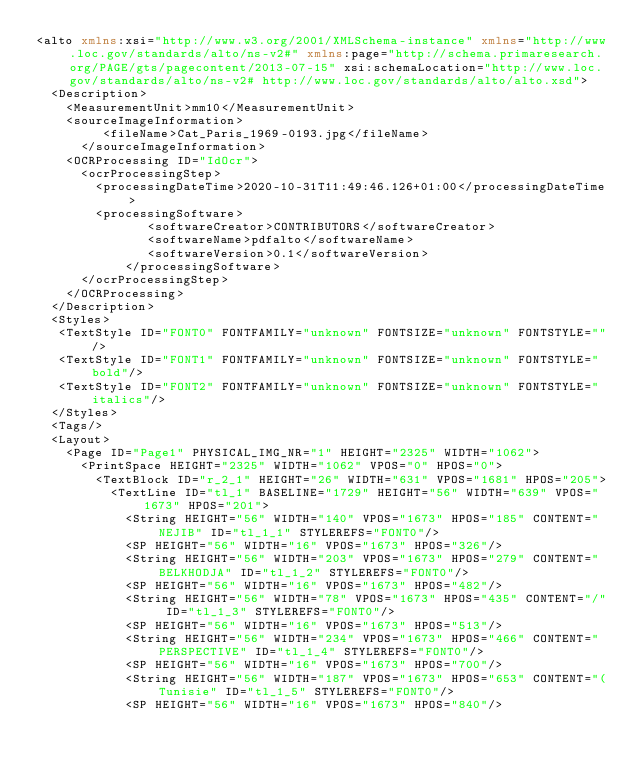<code> <loc_0><loc_0><loc_500><loc_500><_XML_><alto xmlns:xsi="http://www.w3.org/2001/XMLSchema-instance" xmlns="http://www.loc.gov/standards/alto/ns-v2#" xmlns:page="http://schema.primaresearch.org/PAGE/gts/pagecontent/2013-07-15" xsi:schemaLocation="http://www.loc.gov/standards/alto/ns-v2# http://www.loc.gov/standards/alto/alto.xsd">
  <Description>
    <MeasurementUnit>mm10</MeasurementUnit>
    <sourceImageInformation>
         <fileName>Cat_Paris_1969-0193.jpg</fileName>
      </sourceImageInformation>
    <OCRProcessing ID="IdOcr">
      <ocrProcessingStep>
        <processingDateTime>2020-10-31T11:49:46.126+01:00</processingDateTime>
        <processingSoftware>
               <softwareCreator>CONTRIBUTORS</softwareCreator>
               <softwareName>pdfalto</softwareName>
               <softwareVersion>0.1</softwareVersion>
            </processingSoftware>
      </ocrProcessingStep>
    </OCRProcessing>
  </Description>
  <Styles>
   <TextStyle ID="FONT0" FONTFAMILY="unknown" FONTSIZE="unknown" FONTSTYLE=""/>
   <TextStyle ID="FONT1" FONTFAMILY="unknown" FONTSIZE="unknown" FONTSTYLE="bold"/>
   <TextStyle ID="FONT2" FONTFAMILY="unknown" FONTSIZE="unknown" FONTSTYLE="italics"/>
  </Styles>
  <Tags/>
  <Layout>
    <Page ID="Page1" PHYSICAL_IMG_NR="1" HEIGHT="2325" WIDTH="1062">
      <PrintSpace HEIGHT="2325" WIDTH="1062" VPOS="0" HPOS="0">
        <TextBlock ID="r_2_1" HEIGHT="26" WIDTH="631" VPOS="1681" HPOS="205">
          <TextLine ID="tl_1" BASELINE="1729" HEIGHT="56" WIDTH="639" VPOS="1673" HPOS="201">
            <String HEIGHT="56" WIDTH="140" VPOS="1673" HPOS="185" CONTENT="NEJIB" ID="tl_1_1" STYLEREFS="FONT0"/>
            <SP HEIGHT="56" WIDTH="16" VPOS="1673" HPOS="326"/>
            <String HEIGHT="56" WIDTH="203" VPOS="1673" HPOS="279" CONTENT="BELKHODJA" ID="tl_1_2" STYLEREFS="FONT0"/>
            <SP HEIGHT="56" WIDTH="16" VPOS="1673" HPOS="482"/>
            <String HEIGHT="56" WIDTH="78" VPOS="1673" HPOS="435" CONTENT="/" ID="tl_1_3" STYLEREFS="FONT0"/>
            <SP HEIGHT="56" WIDTH="16" VPOS="1673" HPOS="513"/>
            <String HEIGHT="56" WIDTH="234" VPOS="1673" HPOS="466" CONTENT="PERSPECTIVE" ID="tl_1_4" STYLEREFS="FONT0"/>
            <SP HEIGHT="56" WIDTH="16" VPOS="1673" HPOS="700"/>
            <String HEIGHT="56" WIDTH="187" VPOS="1673" HPOS="653" CONTENT="(Tunisie" ID="tl_1_5" STYLEREFS="FONT0"/>
            <SP HEIGHT="56" WIDTH="16" VPOS="1673" HPOS="840"/></code> 